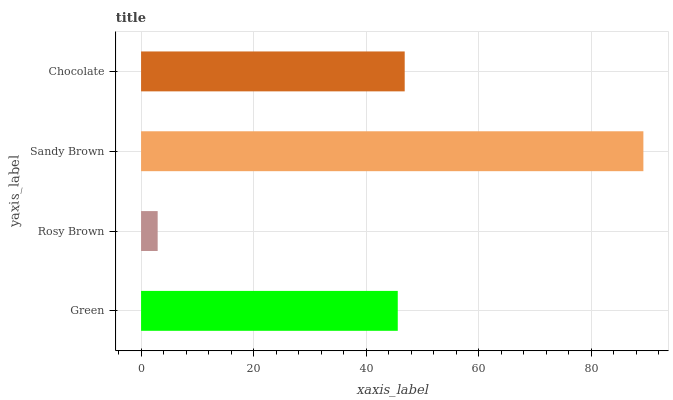Is Rosy Brown the minimum?
Answer yes or no. Yes. Is Sandy Brown the maximum?
Answer yes or no. Yes. Is Sandy Brown the minimum?
Answer yes or no. No. Is Rosy Brown the maximum?
Answer yes or no. No. Is Sandy Brown greater than Rosy Brown?
Answer yes or no. Yes. Is Rosy Brown less than Sandy Brown?
Answer yes or no. Yes. Is Rosy Brown greater than Sandy Brown?
Answer yes or no. No. Is Sandy Brown less than Rosy Brown?
Answer yes or no. No. Is Chocolate the high median?
Answer yes or no. Yes. Is Green the low median?
Answer yes or no. Yes. Is Green the high median?
Answer yes or no. No. Is Sandy Brown the low median?
Answer yes or no. No. 